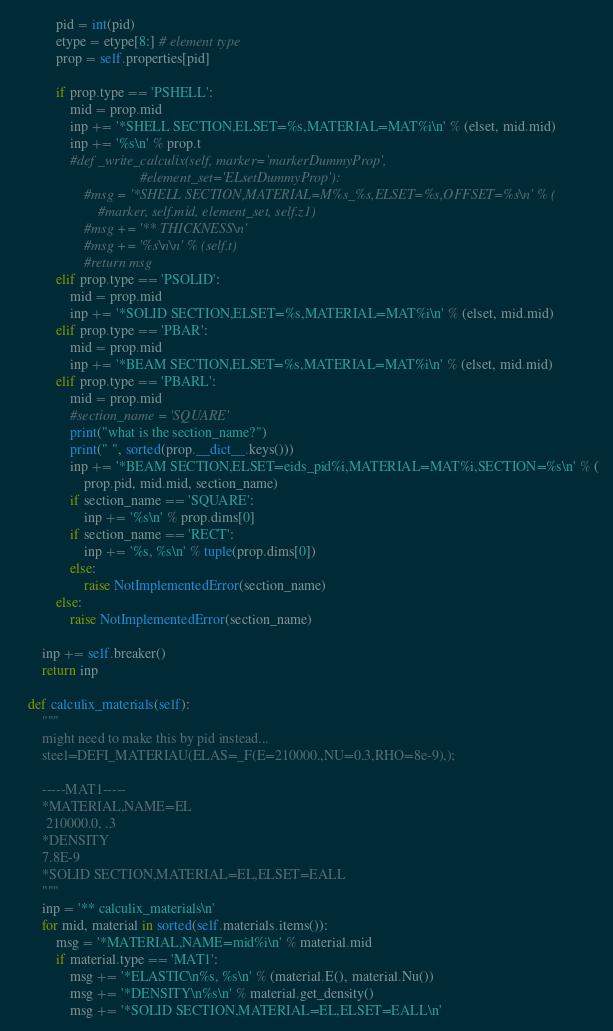<code> <loc_0><loc_0><loc_500><loc_500><_Python_>            pid = int(pid)
            etype = etype[8:] # element type
            prop = self.properties[pid]

            if prop.type == 'PSHELL':
                mid = prop.mid
                inp += '*SHELL SECTION,ELSET=%s,MATERIAL=MAT%i\n' % (elset, mid.mid)
                inp += '%s\n' % prop.t
                #def _write_calculix(self, marker='markerDummyProp',
                                    #element_set='ELsetDummyProp'):
                    #msg = '*SHELL SECTION,MATERIAL=M%s_%s,ELSET=%s,OFFSET=%s\n' % (
                        #marker, self.mid, element_set, self.z1)
                    #msg += '** THICKNESS\n'
                    #msg += '%s\n\n' % (self.t)
                    #return msg
            elif prop.type == 'PSOLID':
                mid = prop.mid
                inp += '*SOLID SECTION,ELSET=%s,MATERIAL=MAT%i\n' % (elset, mid.mid)
            elif prop.type == 'PBAR':
                mid = prop.mid
                inp += '*BEAM SECTION,ELSET=%s,MATERIAL=MAT%i\n' % (elset, mid.mid)
            elif prop.type == 'PBARL':
                mid = prop.mid
                #section_name = 'SQUARE'
                print("what is the section_name?")
                print(" ", sorted(prop.__dict__.keys()))
                inp += '*BEAM SECTION,ELSET=eids_pid%i,MATERIAL=MAT%i,SECTION=%s\n' % (
                    prop.pid, mid.mid, section_name)
                if section_name == 'SQUARE':
                    inp += '%s\n' % prop.dims[0]
                if section_name == 'RECT':
                    inp += '%s, %s\n' % tuple(prop.dims[0])
                else:
                    raise NotImplementedError(section_name)
            else:
                raise NotImplementedError(section_name)

        inp += self.breaker()
        return inp

    def calculix_materials(self):
        """
        might need to make this by pid instead...
        steel=DEFI_MATERIAU(ELAS=_F(E=210000.,NU=0.3,RHO=8e-9),);

        -----MAT1-----
        *MATERIAL,NAME=EL
         210000.0, .3
        *DENSITY
        7.8E-9
        *SOLID SECTION,MATERIAL=EL,ELSET=EALL
        """
        inp = '** calculix_materials\n'
        for mid, material in sorted(self.materials.items()):
            msg = '*MATERIAL,NAME=mid%i\n' % material.mid
            if material.type == 'MAT1':
                msg += '*ELASTIC\n%s, %s\n' % (material.E(), material.Nu())
                msg += '*DENSITY\n%s\n' % material.get_density()
                msg += '*SOLID SECTION,MATERIAL=EL,ELSET=EALL\n'</code> 